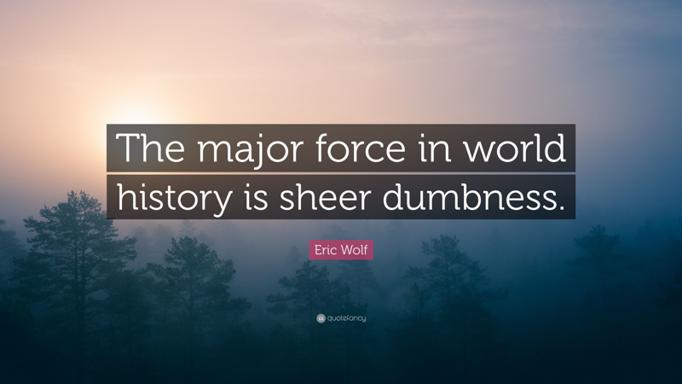What emotions does the combination of the quote and the image evoke? The combination of the stark, powerful quote and the tranquil yet obscure image evokes a blend of contemplation and caution. It resonates a feeling of reflection on past mistakes caused by lack of clarity or understanding, while also invoking a serene call to think wisely about future decisions. Does this evoke a sense of urgency for change in how decisions are made in global contexts? Absolutely, the evocation of reflection and caution in the image, paired with the quote, serves as a subtle yet potent call to action. It urges a reassessment of how decisions are made on a global scale, emphasizing the necessity for greater foresight, wisdom, and informed deliberation in shaping a better historical path forward. 